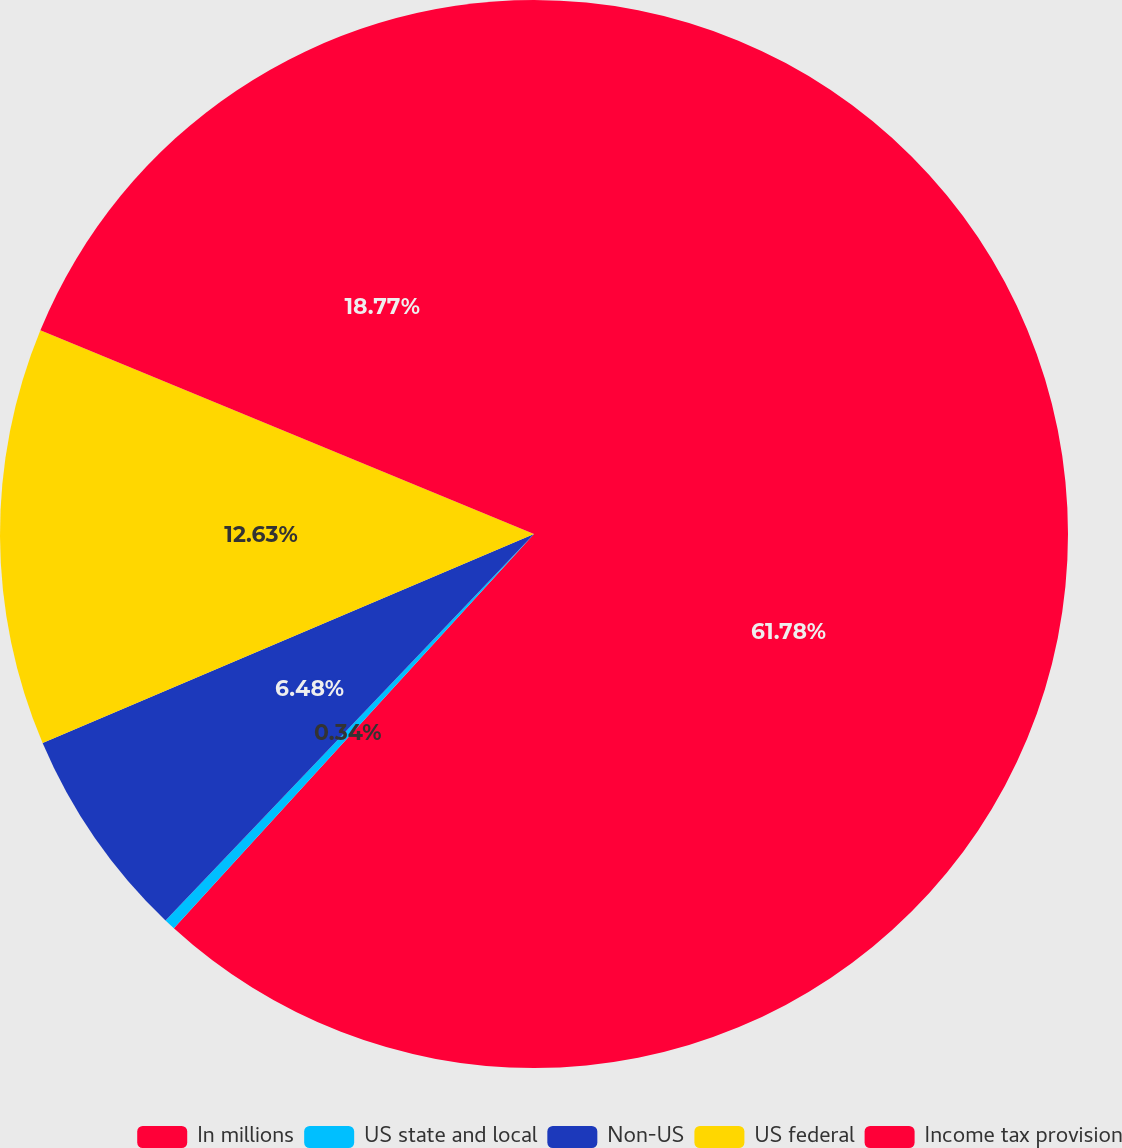Convert chart to OTSL. <chart><loc_0><loc_0><loc_500><loc_500><pie_chart><fcel>In millions<fcel>US state and local<fcel>Non-US<fcel>US federal<fcel>Income tax provision<nl><fcel>61.78%<fcel>0.34%<fcel>6.48%<fcel>12.63%<fcel>18.77%<nl></chart> 